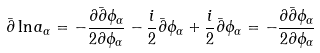Convert formula to latex. <formula><loc_0><loc_0><loc_500><loc_500>\bar { \partial } \ln a _ { \alpha } = - \frac { \partial \bar { \partial } \phi _ { \alpha } } { 2 \partial \phi _ { \alpha } } - \frac { i } { 2 } \bar { \partial } \phi _ { \alpha } + \frac { i } { 2 } \bar { \partial } \phi _ { \alpha } = - \frac { \partial \bar { \partial } \phi _ { \alpha } } { 2 \partial \phi _ { \alpha } }</formula> 